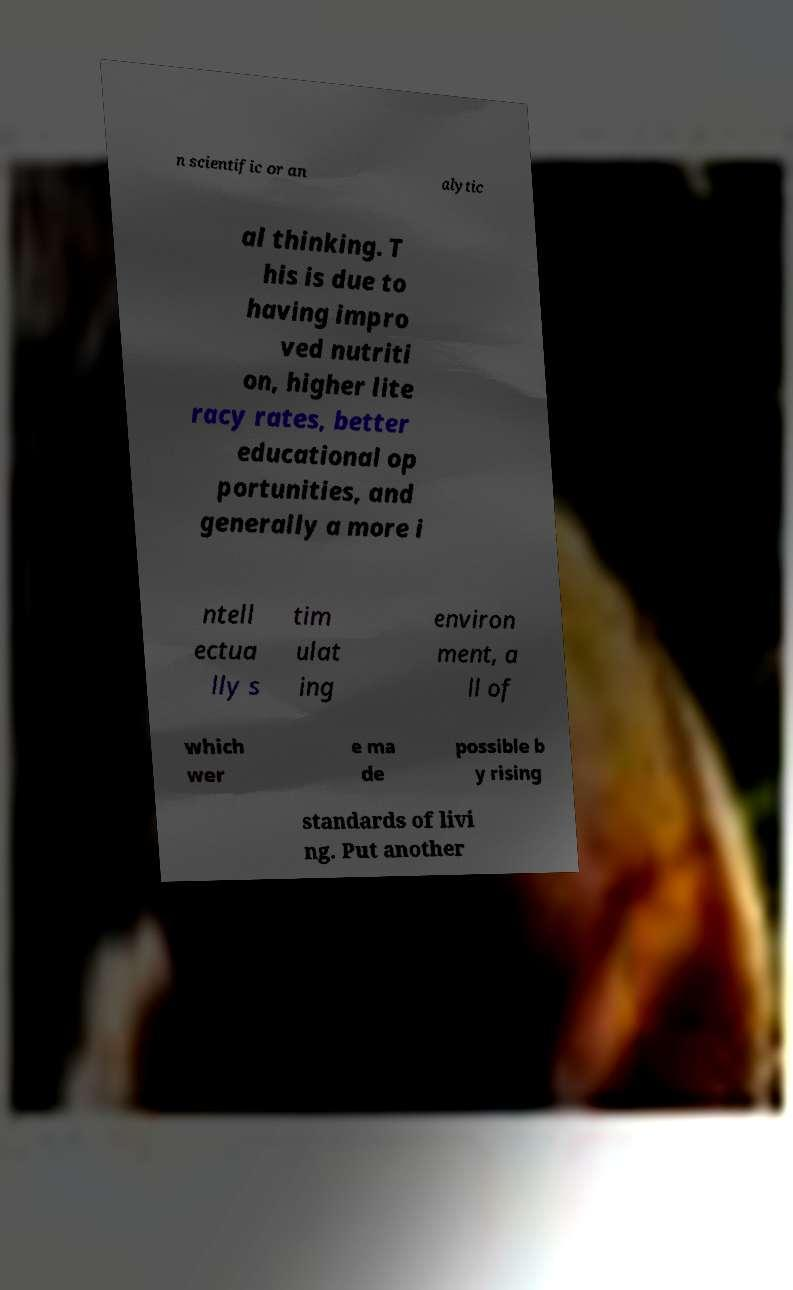There's text embedded in this image that I need extracted. Can you transcribe it verbatim? n scientific or an alytic al thinking. T his is due to having impro ved nutriti on, higher lite racy rates, better educational op portunities, and generally a more i ntell ectua lly s tim ulat ing environ ment, a ll of which wer e ma de possible b y rising standards of livi ng. Put another 